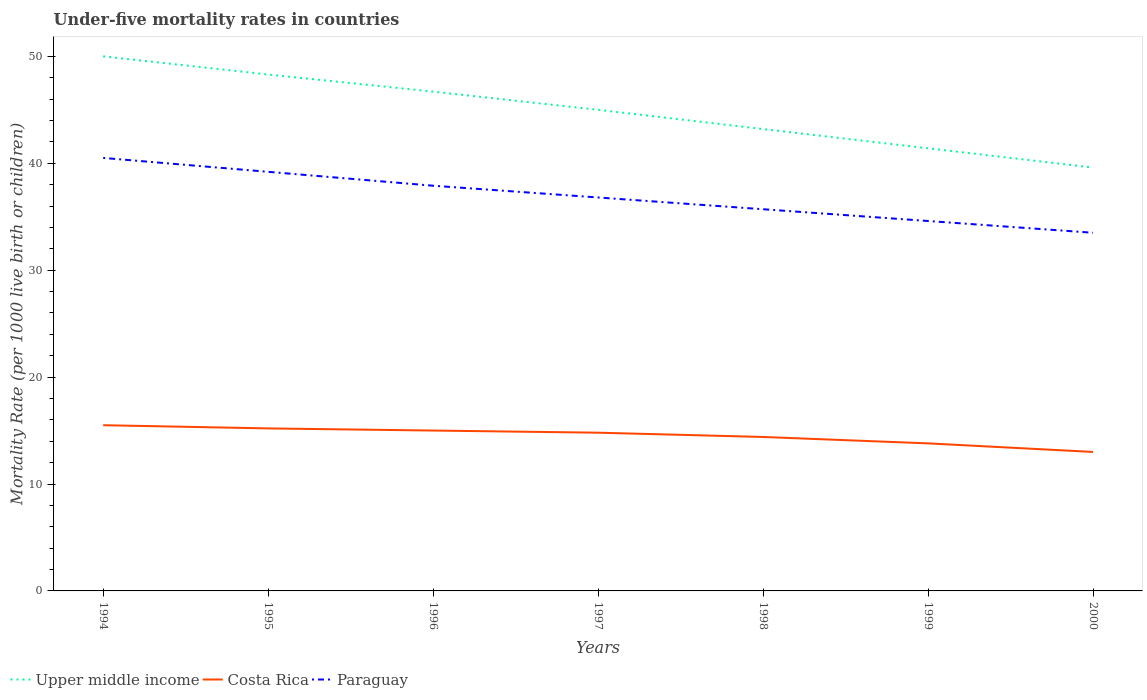In which year was the under-five mortality rate in Upper middle income maximum?
Provide a short and direct response. 2000. What is the total under-five mortality rate in Paraguay in the graph?
Your answer should be very brief. 2.4. What is the difference between the highest and the second highest under-five mortality rate in Costa Rica?
Offer a terse response. 2.5. Is the under-five mortality rate in Upper middle income strictly greater than the under-five mortality rate in Paraguay over the years?
Offer a very short reply. No. How many years are there in the graph?
Your response must be concise. 7. What is the difference between two consecutive major ticks on the Y-axis?
Your answer should be very brief. 10. Does the graph contain any zero values?
Your answer should be compact. No. Does the graph contain grids?
Give a very brief answer. No. Where does the legend appear in the graph?
Give a very brief answer. Bottom left. How many legend labels are there?
Provide a short and direct response. 3. What is the title of the graph?
Provide a succinct answer. Under-five mortality rates in countries. Does "High income: OECD" appear as one of the legend labels in the graph?
Provide a short and direct response. No. What is the label or title of the X-axis?
Ensure brevity in your answer.  Years. What is the label or title of the Y-axis?
Offer a terse response. Mortality Rate (per 1000 live birth or children). What is the Mortality Rate (per 1000 live birth or children) of Upper middle income in 1994?
Keep it short and to the point. 50. What is the Mortality Rate (per 1000 live birth or children) of Costa Rica in 1994?
Offer a very short reply. 15.5. What is the Mortality Rate (per 1000 live birth or children) of Paraguay in 1994?
Provide a short and direct response. 40.5. What is the Mortality Rate (per 1000 live birth or children) in Upper middle income in 1995?
Offer a terse response. 48.3. What is the Mortality Rate (per 1000 live birth or children) of Paraguay in 1995?
Keep it short and to the point. 39.2. What is the Mortality Rate (per 1000 live birth or children) of Upper middle income in 1996?
Provide a short and direct response. 46.7. What is the Mortality Rate (per 1000 live birth or children) of Paraguay in 1996?
Provide a short and direct response. 37.9. What is the Mortality Rate (per 1000 live birth or children) in Upper middle income in 1997?
Keep it short and to the point. 45. What is the Mortality Rate (per 1000 live birth or children) of Costa Rica in 1997?
Make the answer very short. 14.8. What is the Mortality Rate (per 1000 live birth or children) in Paraguay in 1997?
Keep it short and to the point. 36.8. What is the Mortality Rate (per 1000 live birth or children) in Upper middle income in 1998?
Your answer should be very brief. 43.2. What is the Mortality Rate (per 1000 live birth or children) of Costa Rica in 1998?
Your response must be concise. 14.4. What is the Mortality Rate (per 1000 live birth or children) of Paraguay in 1998?
Give a very brief answer. 35.7. What is the Mortality Rate (per 1000 live birth or children) in Upper middle income in 1999?
Keep it short and to the point. 41.4. What is the Mortality Rate (per 1000 live birth or children) in Costa Rica in 1999?
Provide a succinct answer. 13.8. What is the Mortality Rate (per 1000 live birth or children) of Paraguay in 1999?
Your answer should be compact. 34.6. What is the Mortality Rate (per 1000 live birth or children) in Upper middle income in 2000?
Your answer should be very brief. 39.6. What is the Mortality Rate (per 1000 live birth or children) of Costa Rica in 2000?
Your response must be concise. 13. What is the Mortality Rate (per 1000 live birth or children) of Paraguay in 2000?
Your answer should be compact. 33.5. Across all years, what is the maximum Mortality Rate (per 1000 live birth or children) in Upper middle income?
Provide a succinct answer. 50. Across all years, what is the maximum Mortality Rate (per 1000 live birth or children) of Costa Rica?
Make the answer very short. 15.5. Across all years, what is the maximum Mortality Rate (per 1000 live birth or children) of Paraguay?
Provide a succinct answer. 40.5. Across all years, what is the minimum Mortality Rate (per 1000 live birth or children) in Upper middle income?
Offer a terse response. 39.6. Across all years, what is the minimum Mortality Rate (per 1000 live birth or children) in Costa Rica?
Make the answer very short. 13. Across all years, what is the minimum Mortality Rate (per 1000 live birth or children) of Paraguay?
Offer a terse response. 33.5. What is the total Mortality Rate (per 1000 live birth or children) of Upper middle income in the graph?
Your answer should be very brief. 314.2. What is the total Mortality Rate (per 1000 live birth or children) of Costa Rica in the graph?
Keep it short and to the point. 101.7. What is the total Mortality Rate (per 1000 live birth or children) in Paraguay in the graph?
Your answer should be compact. 258.2. What is the difference between the Mortality Rate (per 1000 live birth or children) of Upper middle income in 1994 and that in 1996?
Offer a terse response. 3.3. What is the difference between the Mortality Rate (per 1000 live birth or children) of Costa Rica in 1994 and that in 1996?
Keep it short and to the point. 0.5. What is the difference between the Mortality Rate (per 1000 live birth or children) of Upper middle income in 1994 and that in 1997?
Provide a short and direct response. 5. What is the difference between the Mortality Rate (per 1000 live birth or children) of Costa Rica in 1994 and that in 1997?
Make the answer very short. 0.7. What is the difference between the Mortality Rate (per 1000 live birth or children) in Upper middle income in 1994 and that in 1998?
Make the answer very short. 6.8. What is the difference between the Mortality Rate (per 1000 live birth or children) in Paraguay in 1994 and that in 1998?
Offer a very short reply. 4.8. What is the difference between the Mortality Rate (per 1000 live birth or children) in Upper middle income in 1994 and that in 1999?
Keep it short and to the point. 8.6. What is the difference between the Mortality Rate (per 1000 live birth or children) of Costa Rica in 1994 and that in 1999?
Ensure brevity in your answer.  1.7. What is the difference between the Mortality Rate (per 1000 live birth or children) of Paraguay in 1994 and that in 1999?
Ensure brevity in your answer.  5.9. What is the difference between the Mortality Rate (per 1000 live birth or children) in Upper middle income in 1994 and that in 2000?
Provide a short and direct response. 10.4. What is the difference between the Mortality Rate (per 1000 live birth or children) in Costa Rica in 1994 and that in 2000?
Offer a terse response. 2.5. What is the difference between the Mortality Rate (per 1000 live birth or children) of Paraguay in 1994 and that in 2000?
Offer a very short reply. 7. What is the difference between the Mortality Rate (per 1000 live birth or children) of Upper middle income in 1995 and that in 1996?
Keep it short and to the point. 1.6. What is the difference between the Mortality Rate (per 1000 live birth or children) in Paraguay in 1995 and that in 1997?
Offer a very short reply. 2.4. What is the difference between the Mortality Rate (per 1000 live birth or children) in Costa Rica in 1995 and that in 1998?
Ensure brevity in your answer.  0.8. What is the difference between the Mortality Rate (per 1000 live birth or children) in Paraguay in 1995 and that in 1998?
Your response must be concise. 3.5. What is the difference between the Mortality Rate (per 1000 live birth or children) in Costa Rica in 1995 and that in 1999?
Offer a very short reply. 1.4. What is the difference between the Mortality Rate (per 1000 live birth or children) of Paraguay in 1995 and that in 1999?
Keep it short and to the point. 4.6. What is the difference between the Mortality Rate (per 1000 live birth or children) in Upper middle income in 1995 and that in 2000?
Your response must be concise. 8.7. What is the difference between the Mortality Rate (per 1000 live birth or children) in Costa Rica in 1995 and that in 2000?
Your answer should be compact. 2.2. What is the difference between the Mortality Rate (per 1000 live birth or children) in Paraguay in 1995 and that in 2000?
Provide a short and direct response. 5.7. What is the difference between the Mortality Rate (per 1000 live birth or children) in Upper middle income in 1996 and that in 1997?
Your answer should be very brief. 1.7. What is the difference between the Mortality Rate (per 1000 live birth or children) of Costa Rica in 1996 and that in 1997?
Your answer should be compact. 0.2. What is the difference between the Mortality Rate (per 1000 live birth or children) of Paraguay in 1996 and that in 1997?
Your response must be concise. 1.1. What is the difference between the Mortality Rate (per 1000 live birth or children) of Costa Rica in 1996 and that in 1999?
Provide a short and direct response. 1.2. What is the difference between the Mortality Rate (per 1000 live birth or children) of Paraguay in 1996 and that in 1999?
Provide a short and direct response. 3.3. What is the difference between the Mortality Rate (per 1000 live birth or children) of Upper middle income in 1996 and that in 2000?
Provide a short and direct response. 7.1. What is the difference between the Mortality Rate (per 1000 live birth or children) in Costa Rica in 1996 and that in 2000?
Give a very brief answer. 2. What is the difference between the Mortality Rate (per 1000 live birth or children) of Paraguay in 1996 and that in 2000?
Make the answer very short. 4.4. What is the difference between the Mortality Rate (per 1000 live birth or children) in Upper middle income in 1997 and that in 1999?
Give a very brief answer. 3.6. What is the difference between the Mortality Rate (per 1000 live birth or children) in Paraguay in 1997 and that in 1999?
Keep it short and to the point. 2.2. What is the difference between the Mortality Rate (per 1000 live birth or children) of Costa Rica in 1997 and that in 2000?
Ensure brevity in your answer.  1.8. What is the difference between the Mortality Rate (per 1000 live birth or children) in Paraguay in 1998 and that in 1999?
Make the answer very short. 1.1. What is the difference between the Mortality Rate (per 1000 live birth or children) of Upper middle income in 1999 and that in 2000?
Your answer should be very brief. 1.8. What is the difference between the Mortality Rate (per 1000 live birth or children) in Costa Rica in 1999 and that in 2000?
Provide a short and direct response. 0.8. What is the difference between the Mortality Rate (per 1000 live birth or children) in Upper middle income in 1994 and the Mortality Rate (per 1000 live birth or children) in Costa Rica in 1995?
Your answer should be very brief. 34.8. What is the difference between the Mortality Rate (per 1000 live birth or children) in Upper middle income in 1994 and the Mortality Rate (per 1000 live birth or children) in Paraguay in 1995?
Provide a succinct answer. 10.8. What is the difference between the Mortality Rate (per 1000 live birth or children) in Costa Rica in 1994 and the Mortality Rate (per 1000 live birth or children) in Paraguay in 1995?
Offer a terse response. -23.7. What is the difference between the Mortality Rate (per 1000 live birth or children) in Upper middle income in 1994 and the Mortality Rate (per 1000 live birth or children) in Paraguay in 1996?
Ensure brevity in your answer.  12.1. What is the difference between the Mortality Rate (per 1000 live birth or children) of Costa Rica in 1994 and the Mortality Rate (per 1000 live birth or children) of Paraguay in 1996?
Offer a terse response. -22.4. What is the difference between the Mortality Rate (per 1000 live birth or children) of Upper middle income in 1994 and the Mortality Rate (per 1000 live birth or children) of Costa Rica in 1997?
Provide a short and direct response. 35.2. What is the difference between the Mortality Rate (per 1000 live birth or children) of Upper middle income in 1994 and the Mortality Rate (per 1000 live birth or children) of Paraguay in 1997?
Offer a terse response. 13.2. What is the difference between the Mortality Rate (per 1000 live birth or children) in Costa Rica in 1994 and the Mortality Rate (per 1000 live birth or children) in Paraguay in 1997?
Give a very brief answer. -21.3. What is the difference between the Mortality Rate (per 1000 live birth or children) of Upper middle income in 1994 and the Mortality Rate (per 1000 live birth or children) of Costa Rica in 1998?
Provide a short and direct response. 35.6. What is the difference between the Mortality Rate (per 1000 live birth or children) of Costa Rica in 1994 and the Mortality Rate (per 1000 live birth or children) of Paraguay in 1998?
Ensure brevity in your answer.  -20.2. What is the difference between the Mortality Rate (per 1000 live birth or children) of Upper middle income in 1994 and the Mortality Rate (per 1000 live birth or children) of Costa Rica in 1999?
Your answer should be very brief. 36.2. What is the difference between the Mortality Rate (per 1000 live birth or children) of Costa Rica in 1994 and the Mortality Rate (per 1000 live birth or children) of Paraguay in 1999?
Offer a terse response. -19.1. What is the difference between the Mortality Rate (per 1000 live birth or children) of Upper middle income in 1994 and the Mortality Rate (per 1000 live birth or children) of Costa Rica in 2000?
Make the answer very short. 37. What is the difference between the Mortality Rate (per 1000 live birth or children) in Costa Rica in 1994 and the Mortality Rate (per 1000 live birth or children) in Paraguay in 2000?
Your response must be concise. -18. What is the difference between the Mortality Rate (per 1000 live birth or children) in Upper middle income in 1995 and the Mortality Rate (per 1000 live birth or children) in Costa Rica in 1996?
Your answer should be very brief. 33.3. What is the difference between the Mortality Rate (per 1000 live birth or children) of Costa Rica in 1995 and the Mortality Rate (per 1000 live birth or children) of Paraguay in 1996?
Keep it short and to the point. -22.7. What is the difference between the Mortality Rate (per 1000 live birth or children) in Upper middle income in 1995 and the Mortality Rate (per 1000 live birth or children) in Costa Rica in 1997?
Keep it short and to the point. 33.5. What is the difference between the Mortality Rate (per 1000 live birth or children) in Upper middle income in 1995 and the Mortality Rate (per 1000 live birth or children) in Paraguay in 1997?
Your answer should be very brief. 11.5. What is the difference between the Mortality Rate (per 1000 live birth or children) of Costa Rica in 1995 and the Mortality Rate (per 1000 live birth or children) of Paraguay in 1997?
Offer a terse response. -21.6. What is the difference between the Mortality Rate (per 1000 live birth or children) of Upper middle income in 1995 and the Mortality Rate (per 1000 live birth or children) of Costa Rica in 1998?
Your response must be concise. 33.9. What is the difference between the Mortality Rate (per 1000 live birth or children) of Upper middle income in 1995 and the Mortality Rate (per 1000 live birth or children) of Paraguay in 1998?
Give a very brief answer. 12.6. What is the difference between the Mortality Rate (per 1000 live birth or children) of Costa Rica in 1995 and the Mortality Rate (per 1000 live birth or children) of Paraguay in 1998?
Your answer should be compact. -20.5. What is the difference between the Mortality Rate (per 1000 live birth or children) in Upper middle income in 1995 and the Mortality Rate (per 1000 live birth or children) in Costa Rica in 1999?
Provide a short and direct response. 34.5. What is the difference between the Mortality Rate (per 1000 live birth or children) of Upper middle income in 1995 and the Mortality Rate (per 1000 live birth or children) of Paraguay in 1999?
Provide a short and direct response. 13.7. What is the difference between the Mortality Rate (per 1000 live birth or children) in Costa Rica in 1995 and the Mortality Rate (per 1000 live birth or children) in Paraguay in 1999?
Give a very brief answer. -19.4. What is the difference between the Mortality Rate (per 1000 live birth or children) of Upper middle income in 1995 and the Mortality Rate (per 1000 live birth or children) of Costa Rica in 2000?
Provide a short and direct response. 35.3. What is the difference between the Mortality Rate (per 1000 live birth or children) in Costa Rica in 1995 and the Mortality Rate (per 1000 live birth or children) in Paraguay in 2000?
Provide a succinct answer. -18.3. What is the difference between the Mortality Rate (per 1000 live birth or children) in Upper middle income in 1996 and the Mortality Rate (per 1000 live birth or children) in Costa Rica in 1997?
Your response must be concise. 31.9. What is the difference between the Mortality Rate (per 1000 live birth or children) of Upper middle income in 1996 and the Mortality Rate (per 1000 live birth or children) of Paraguay in 1997?
Give a very brief answer. 9.9. What is the difference between the Mortality Rate (per 1000 live birth or children) in Costa Rica in 1996 and the Mortality Rate (per 1000 live birth or children) in Paraguay in 1997?
Provide a succinct answer. -21.8. What is the difference between the Mortality Rate (per 1000 live birth or children) in Upper middle income in 1996 and the Mortality Rate (per 1000 live birth or children) in Costa Rica in 1998?
Make the answer very short. 32.3. What is the difference between the Mortality Rate (per 1000 live birth or children) of Costa Rica in 1996 and the Mortality Rate (per 1000 live birth or children) of Paraguay in 1998?
Give a very brief answer. -20.7. What is the difference between the Mortality Rate (per 1000 live birth or children) of Upper middle income in 1996 and the Mortality Rate (per 1000 live birth or children) of Costa Rica in 1999?
Make the answer very short. 32.9. What is the difference between the Mortality Rate (per 1000 live birth or children) in Upper middle income in 1996 and the Mortality Rate (per 1000 live birth or children) in Paraguay in 1999?
Your response must be concise. 12.1. What is the difference between the Mortality Rate (per 1000 live birth or children) of Costa Rica in 1996 and the Mortality Rate (per 1000 live birth or children) of Paraguay in 1999?
Offer a very short reply. -19.6. What is the difference between the Mortality Rate (per 1000 live birth or children) of Upper middle income in 1996 and the Mortality Rate (per 1000 live birth or children) of Costa Rica in 2000?
Your answer should be compact. 33.7. What is the difference between the Mortality Rate (per 1000 live birth or children) of Upper middle income in 1996 and the Mortality Rate (per 1000 live birth or children) of Paraguay in 2000?
Your response must be concise. 13.2. What is the difference between the Mortality Rate (per 1000 live birth or children) in Costa Rica in 1996 and the Mortality Rate (per 1000 live birth or children) in Paraguay in 2000?
Your answer should be very brief. -18.5. What is the difference between the Mortality Rate (per 1000 live birth or children) of Upper middle income in 1997 and the Mortality Rate (per 1000 live birth or children) of Costa Rica in 1998?
Your answer should be very brief. 30.6. What is the difference between the Mortality Rate (per 1000 live birth or children) in Costa Rica in 1997 and the Mortality Rate (per 1000 live birth or children) in Paraguay in 1998?
Offer a very short reply. -20.9. What is the difference between the Mortality Rate (per 1000 live birth or children) of Upper middle income in 1997 and the Mortality Rate (per 1000 live birth or children) of Costa Rica in 1999?
Provide a succinct answer. 31.2. What is the difference between the Mortality Rate (per 1000 live birth or children) in Upper middle income in 1997 and the Mortality Rate (per 1000 live birth or children) in Paraguay in 1999?
Offer a terse response. 10.4. What is the difference between the Mortality Rate (per 1000 live birth or children) in Costa Rica in 1997 and the Mortality Rate (per 1000 live birth or children) in Paraguay in 1999?
Offer a terse response. -19.8. What is the difference between the Mortality Rate (per 1000 live birth or children) in Costa Rica in 1997 and the Mortality Rate (per 1000 live birth or children) in Paraguay in 2000?
Your response must be concise. -18.7. What is the difference between the Mortality Rate (per 1000 live birth or children) in Upper middle income in 1998 and the Mortality Rate (per 1000 live birth or children) in Costa Rica in 1999?
Provide a succinct answer. 29.4. What is the difference between the Mortality Rate (per 1000 live birth or children) of Costa Rica in 1998 and the Mortality Rate (per 1000 live birth or children) of Paraguay in 1999?
Your answer should be very brief. -20.2. What is the difference between the Mortality Rate (per 1000 live birth or children) of Upper middle income in 1998 and the Mortality Rate (per 1000 live birth or children) of Costa Rica in 2000?
Offer a very short reply. 30.2. What is the difference between the Mortality Rate (per 1000 live birth or children) of Costa Rica in 1998 and the Mortality Rate (per 1000 live birth or children) of Paraguay in 2000?
Provide a short and direct response. -19.1. What is the difference between the Mortality Rate (per 1000 live birth or children) of Upper middle income in 1999 and the Mortality Rate (per 1000 live birth or children) of Costa Rica in 2000?
Provide a short and direct response. 28.4. What is the difference between the Mortality Rate (per 1000 live birth or children) of Costa Rica in 1999 and the Mortality Rate (per 1000 live birth or children) of Paraguay in 2000?
Make the answer very short. -19.7. What is the average Mortality Rate (per 1000 live birth or children) of Upper middle income per year?
Offer a very short reply. 44.89. What is the average Mortality Rate (per 1000 live birth or children) of Costa Rica per year?
Your response must be concise. 14.53. What is the average Mortality Rate (per 1000 live birth or children) of Paraguay per year?
Your response must be concise. 36.89. In the year 1994, what is the difference between the Mortality Rate (per 1000 live birth or children) of Upper middle income and Mortality Rate (per 1000 live birth or children) of Costa Rica?
Your answer should be compact. 34.5. In the year 1994, what is the difference between the Mortality Rate (per 1000 live birth or children) in Upper middle income and Mortality Rate (per 1000 live birth or children) in Paraguay?
Your answer should be compact. 9.5. In the year 1995, what is the difference between the Mortality Rate (per 1000 live birth or children) in Upper middle income and Mortality Rate (per 1000 live birth or children) in Costa Rica?
Give a very brief answer. 33.1. In the year 1995, what is the difference between the Mortality Rate (per 1000 live birth or children) of Upper middle income and Mortality Rate (per 1000 live birth or children) of Paraguay?
Your response must be concise. 9.1. In the year 1995, what is the difference between the Mortality Rate (per 1000 live birth or children) of Costa Rica and Mortality Rate (per 1000 live birth or children) of Paraguay?
Your answer should be very brief. -24. In the year 1996, what is the difference between the Mortality Rate (per 1000 live birth or children) of Upper middle income and Mortality Rate (per 1000 live birth or children) of Costa Rica?
Your answer should be compact. 31.7. In the year 1996, what is the difference between the Mortality Rate (per 1000 live birth or children) of Upper middle income and Mortality Rate (per 1000 live birth or children) of Paraguay?
Your answer should be very brief. 8.8. In the year 1996, what is the difference between the Mortality Rate (per 1000 live birth or children) in Costa Rica and Mortality Rate (per 1000 live birth or children) in Paraguay?
Your answer should be very brief. -22.9. In the year 1997, what is the difference between the Mortality Rate (per 1000 live birth or children) in Upper middle income and Mortality Rate (per 1000 live birth or children) in Costa Rica?
Your answer should be compact. 30.2. In the year 1997, what is the difference between the Mortality Rate (per 1000 live birth or children) in Upper middle income and Mortality Rate (per 1000 live birth or children) in Paraguay?
Ensure brevity in your answer.  8.2. In the year 1998, what is the difference between the Mortality Rate (per 1000 live birth or children) in Upper middle income and Mortality Rate (per 1000 live birth or children) in Costa Rica?
Your response must be concise. 28.8. In the year 1998, what is the difference between the Mortality Rate (per 1000 live birth or children) in Costa Rica and Mortality Rate (per 1000 live birth or children) in Paraguay?
Offer a very short reply. -21.3. In the year 1999, what is the difference between the Mortality Rate (per 1000 live birth or children) of Upper middle income and Mortality Rate (per 1000 live birth or children) of Costa Rica?
Offer a very short reply. 27.6. In the year 1999, what is the difference between the Mortality Rate (per 1000 live birth or children) in Costa Rica and Mortality Rate (per 1000 live birth or children) in Paraguay?
Your answer should be very brief. -20.8. In the year 2000, what is the difference between the Mortality Rate (per 1000 live birth or children) in Upper middle income and Mortality Rate (per 1000 live birth or children) in Costa Rica?
Provide a short and direct response. 26.6. In the year 2000, what is the difference between the Mortality Rate (per 1000 live birth or children) in Costa Rica and Mortality Rate (per 1000 live birth or children) in Paraguay?
Your answer should be very brief. -20.5. What is the ratio of the Mortality Rate (per 1000 live birth or children) in Upper middle income in 1994 to that in 1995?
Ensure brevity in your answer.  1.04. What is the ratio of the Mortality Rate (per 1000 live birth or children) in Costa Rica in 1994 to that in 1995?
Make the answer very short. 1.02. What is the ratio of the Mortality Rate (per 1000 live birth or children) in Paraguay in 1994 to that in 1995?
Provide a short and direct response. 1.03. What is the ratio of the Mortality Rate (per 1000 live birth or children) of Upper middle income in 1994 to that in 1996?
Provide a short and direct response. 1.07. What is the ratio of the Mortality Rate (per 1000 live birth or children) of Paraguay in 1994 to that in 1996?
Your answer should be compact. 1.07. What is the ratio of the Mortality Rate (per 1000 live birth or children) of Costa Rica in 1994 to that in 1997?
Ensure brevity in your answer.  1.05. What is the ratio of the Mortality Rate (per 1000 live birth or children) in Paraguay in 1994 to that in 1997?
Offer a very short reply. 1.1. What is the ratio of the Mortality Rate (per 1000 live birth or children) of Upper middle income in 1994 to that in 1998?
Provide a succinct answer. 1.16. What is the ratio of the Mortality Rate (per 1000 live birth or children) of Costa Rica in 1994 to that in 1998?
Your answer should be very brief. 1.08. What is the ratio of the Mortality Rate (per 1000 live birth or children) of Paraguay in 1994 to that in 1998?
Ensure brevity in your answer.  1.13. What is the ratio of the Mortality Rate (per 1000 live birth or children) in Upper middle income in 1994 to that in 1999?
Your response must be concise. 1.21. What is the ratio of the Mortality Rate (per 1000 live birth or children) in Costa Rica in 1994 to that in 1999?
Your answer should be very brief. 1.12. What is the ratio of the Mortality Rate (per 1000 live birth or children) in Paraguay in 1994 to that in 1999?
Your answer should be compact. 1.17. What is the ratio of the Mortality Rate (per 1000 live birth or children) of Upper middle income in 1994 to that in 2000?
Offer a very short reply. 1.26. What is the ratio of the Mortality Rate (per 1000 live birth or children) in Costa Rica in 1994 to that in 2000?
Offer a terse response. 1.19. What is the ratio of the Mortality Rate (per 1000 live birth or children) in Paraguay in 1994 to that in 2000?
Your answer should be compact. 1.21. What is the ratio of the Mortality Rate (per 1000 live birth or children) in Upper middle income in 1995 to that in 1996?
Provide a short and direct response. 1.03. What is the ratio of the Mortality Rate (per 1000 live birth or children) in Costa Rica in 1995 to that in 1996?
Provide a short and direct response. 1.01. What is the ratio of the Mortality Rate (per 1000 live birth or children) in Paraguay in 1995 to that in 1996?
Ensure brevity in your answer.  1.03. What is the ratio of the Mortality Rate (per 1000 live birth or children) of Upper middle income in 1995 to that in 1997?
Provide a succinct answer. 1.07. What is the ratio of the Mortality Rate (per 1000 live birth or children) of Paraguay in 1995 to that in 1997?
Provide a succinct answer. 1.07. What is the ratio of the Mortality Rate (per 1000 live birth or children) in Upper middle income in 1995 to that in 1998?
Your answer should be compact. 1.12. What is the ratio of the Mortality Rate (per 1000 live birth or children) of Costa Rica in 1995 to that in 1998?
Your answer should be compact. 1.06. What is the ratio of the Mortality Rate (per 1000 live birth or children) of Paraguay in 1995 to that in 1998?
Keep it short and to the point. 1.1. What is the ratio of the Mortality Rate (per 1000 live birth or children) in Costa Rica in 1995 to that in 1999?
Your response must be concise. 1.1. What is the ratio of the Mortality Rate (per 1000 live birth or children) in Paraguay in 1995 to that in 1999?
Provide a succinct answer. 1.13. What is the ratio of the Mortality Rate (per 1000 live birth or children) of Upper middle income in 1995 to that in 2000?
Offer a very short reply. 1.22. What is the ratio of the Mortality Rate (per 1000 live birth or children) of Costa Rica in 1995 to that in 2000?
Keep it short and to the point. 1.17. What is the ratio of the Mortality Rate (per 1000 live birth or children) of Paraguay in 1995 to that in 2000?
Provide a succinct answer. 1.17. What is the ratio of the Mortality Rate (per 1000 live birth or children) in Upper middle income in 1996 to that in 1997?
Provide a succinct answer. 1.04. What is the ratio of the Mortality Rate (per 1000 live birth or children) in Costa Rica in 1996 to that in 1997?
Keep it short and to the point. 1.01. What is the ratio of the Mortality Rate (per 1000 live birth or children) in Paraguay in 1996 to that in 1997?
Keep it short and to the point. 1.03. What is the ratio of the Mortality Rate (per 1000 live birth or children) of Upper middle income in 1996 to that in 1998?
Your answer should be compact. 1.08. What is the ratio of the Mortality Rate (per 1000 live birth or children) of Costa Rica in 1996 to that in 1998?
Offer a very short reply. 1.04. What is the ratio of the Mortality Rate (per 1000 live birth or children) of Paraguay in 1996 to that in 1998?
Your response must be concise. 1.06. What is the ratio of the Mortality Rate (per 1000 live birth or children) of Upper middle income in 1996 to that in 1999?
Keep it short and to the point. 1.13. What is the ratio of the Mortality Rate (per 1000 live birth or children) of Costa Rica in 1996 to that in 1999?
Provide a short and direct response. 1.09. What is the ratio of the Mortality Rate (per 1000 live birth or children) of Paraguay in 1996 to that in 1999?
Ensure brevity in your answer.  1.1. What is the ratio of the Mortality Rate (per 1000 live birth or children) in Upper middle income in 1996 to that in 2000?
Provide a succinct answer. 1.18. What is the ratio of the Mortality Rate (per 1000 live birth or children) of Costa Rica in 1996 to that in 2000?
Your answer should be compact. 1.15. What is the ratio of the Mortality Rate (per 1000 live birth or children) of Paraguay in 1996 to that in 2000?
Offer a terse response. 1.13. What is the ratio of the Mortality Rate (per 1000 live birth or children) in Upper middle income in 1997 to that in 1998?
Offer a terse response. 1.04. What is the ratio of the Mortality Rate (per 1000 live birth or children) of Costa Rica in 1997 to that in 1998?
Give a very brief answer. 1.03. What is the ratio of the Mortality Rate (per 1000 live birth or children) in Paraguay in 1997 to that in 1998?
Offer a very short reply. 1.03. What is the ratio of the Mortality Rate (per 1000 live birth or children) in Upper middle income in 1997 to that in 1999?
Give a very brief answer. 1.09. What is the ratio of the Mortality Rate (per 1000 live birth or children) of Costa Rica in 1997 to that in 1999?
Your response must be concise. 1.07. What is the ratio of the Mortality Rate (per 1000 live birth or children) of Paraguay in 1997 to that in 1999?
Your answer should be very brief. 1.06. What is the ratio of the Mortality Rate (per 1000 live birth or children) of Upper middle income in 1997 to that in 2000?
Your response must be concise. 1.14. What is the ratio of the Mortality Rate (per 1000 live birth or children) in Costa Rica in 1997 to that in 2000?
Your answer should be compact. 1.14. What is the ratio of the Mortality Rate (per 1000 live birth or children) of Paraguay in 1997 to that in 2000?
Your answer should be very brief. 1.1. What is the ratio of the Mortality Rate (per 1000 live birth or children) in Upper middle income in 1998 to that in 1999?
Your response must be concise. 1.04. What is the ratio of the Mortality Rate (per 1000 live birth or children) in Costa Rica in 1998 to that in 1999?
Your answer should be very brief. 1.04. What is the ratio of the Mortality Rate (per 1000 live birth or children) in Paraguay in 1998 to that in 1999?
Give a very brief answer. 1.03. What is the ratio of the Mortality Rate (per 1000 live birth or children) in Costa Rica in 1998 to that in 2000?
Make the answer very short. 1.11. What is the ratio of the Mortality Rate (per 1000 live birth or children) of Paraguay in 1998 to that in 2000?
Make the answer very short. 1.07. What is the ratio of the Mortality Rate (per 1000 live birth or children) in Upper middle income in 1999 to that in 2000?
Your answer should be very brief. 1.05. What is the ratio of the Mortality Rate (per 1000 live birth or children) of Costa Rica in 1999 to that in 2000?
Keep it short and to the point. 1.06. What is the ratio of the Mortality Rate (per 1000 live birth or children) in Paraguay in 1999 to that in 2000?
Make the answer very short. 1.03. What is the difference between the highest and the second highest Mortality Rate (per 1000 live birth or children) in Upper middle income?
Offer a very short reply. 1.7. What is the difference between the highest and the second highest Mortality Rate (per 1000 live birth or children) in Costa Rica?
Offer a terse response. 0.3. What is the difference between the highest and the second highest Mortality Rate (per 1000 live birth or children) in Paraguay?
Offer a very short reply. 1.3. What is the difference between the highest and the lowest Mortality Rate (per 1000 live birth or children) in Paraguay?
Your response must be concise. 7. 